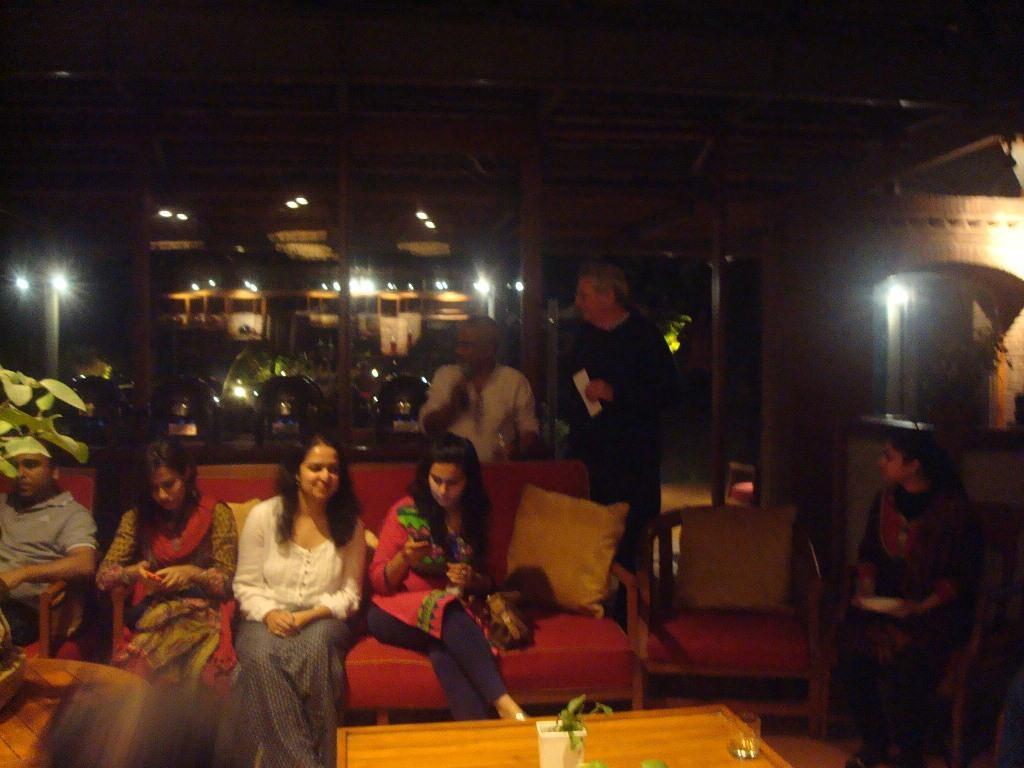Describe this image in one or two sentences. The image is inside the room. In the image there are group of people, three women are sitting on couch. On couch we can see pillows two men are standing. In background we can see some lights,pillars on top we can see roof. On right side there is a woman sitting on chair and holding something in middle there is a table on table we can see plant,flower pot,glass. 